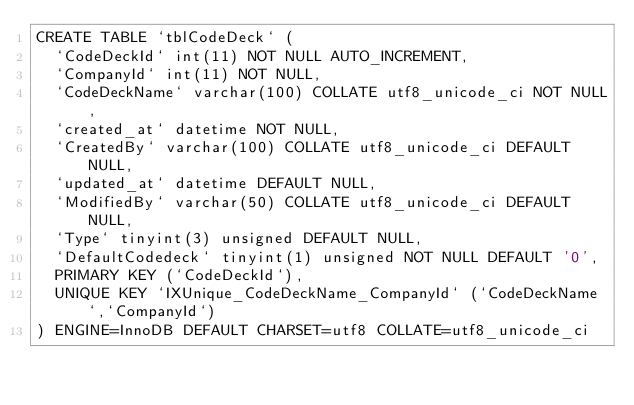Convert code to text. <code><loc_0><loc_0><loc_500><loc_500><_SQL_>CREATE TABLE `tblCodeDeck` (
  `CodeDeckId` int(11) NOT NULL AUTO_INCREMENT,
  `CompanyId` int(11) NOT NULL,
  `CodeDeckName` varchar(100) COLLATE utf8_unicode_ci NOT NULL,
  `created_at` datetime NOT NULL,
  `CreatedBy` varchar(100) COLLATE utf8_unicode_ci DEFAULT NULL,
  `updated_at` datetime DEFAULT NULL,
  `ModifiedBy` varchar(50) COLLATE utf8_unicode_ci DEFAULT NULL,
  `Type` tinyint(3) unsigned DEFAULT NULL,
  `DefaultCodedeck` tinyint(1) unsigned NOT NULL DEFAULT '0',
  PRIMARY KEY (`CodeDeckId`),
  UNIQUE KEY `IXUnique_CodeDeckName_CompanyId` (`CodeDeckName`,`CompanyId`)
) ENGINE=InnoDB DEFAULT CHARSET=utf8 COLLATE=utf8_unicode_ci</code> 